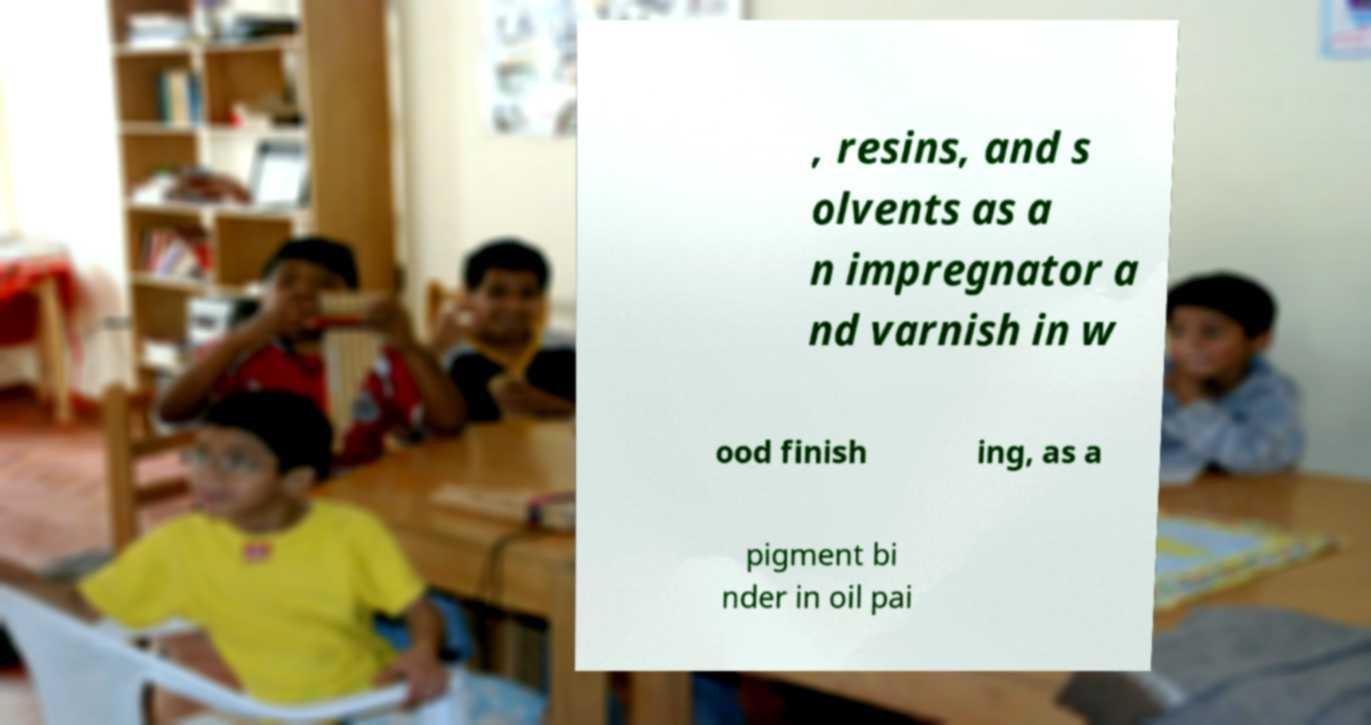Could you extract and type out the text from this image? , resins, and s olvents as a n impregnator a nd varnish in w ood finish ing, as a pigment bi nder in oil pai 